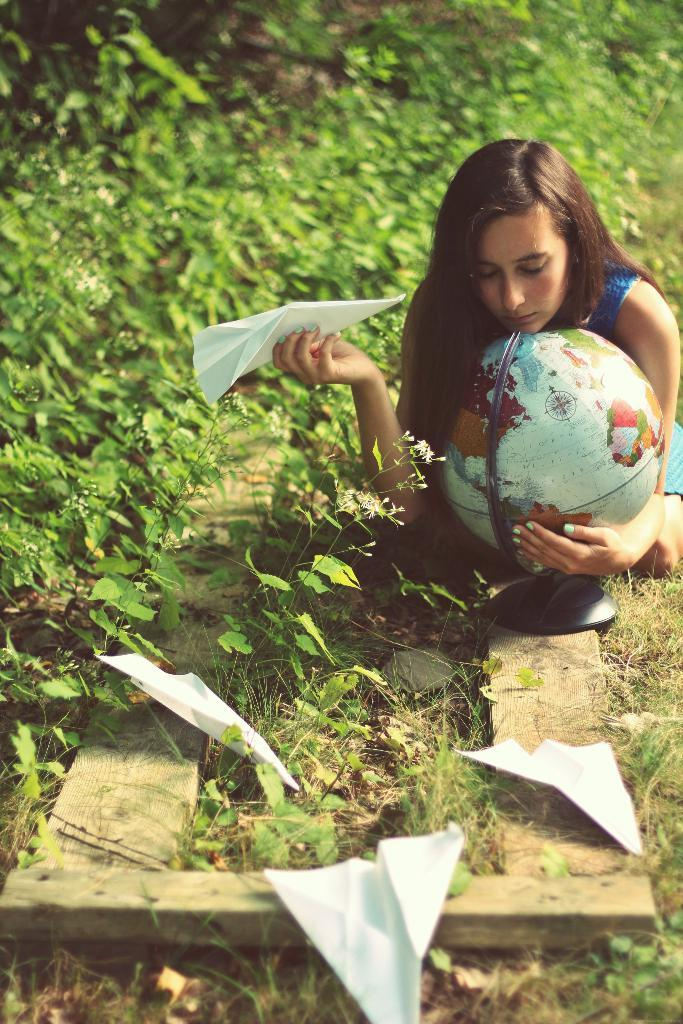Who is present in the image? There is a woman in the image. What is the woman holding in her hands? The woman is holding a globe and a paper. Are there any additional papers visible in the image? Yes, there are papers on wooden planks in the image. What other objects or elements can be seen in the image? There are plants and flowers in the image. What type of teeth can be seen in the image? There are no teeth visible in the image. Is the woman in the image a parent? The image does not provide any information about the woman's parental status. 